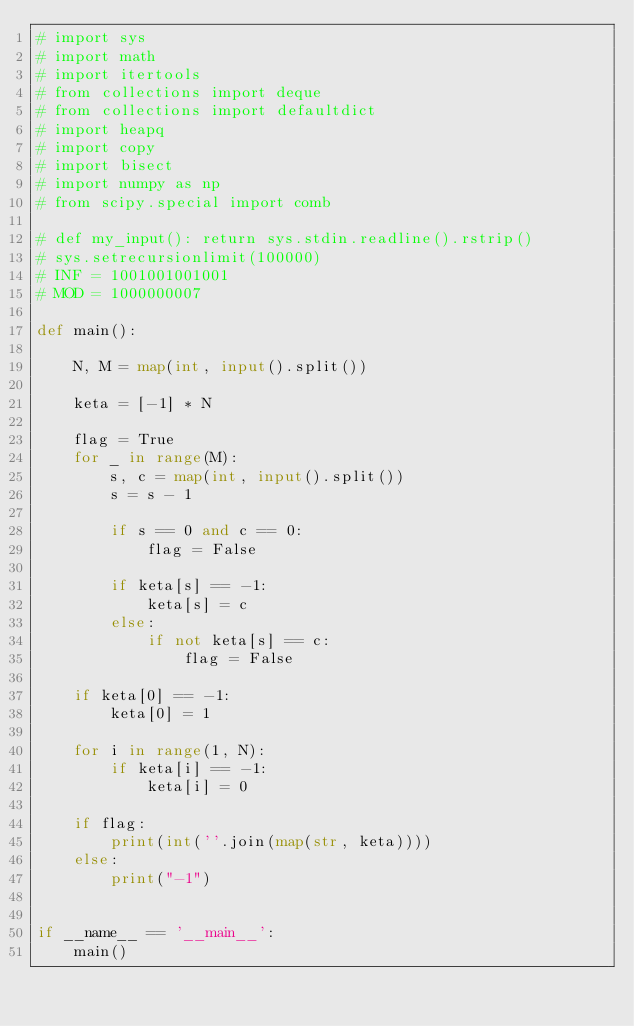Convert code to text. <code><loc_0><loc_0><loc_500><loc_500><_Python_># import sys
# import math
# import itertools
# from collections import deque
# from collections import defaultdict
# import heapq
# import copy
# import bisect
# import numpy as np
# from scipy.special import comb

# def my_input(): return sys.stdin.readline().rstrip()
# sys.setrecursionlimit(100000)
# INF = 1001001001001
# MOD = 1000000007

def main():

    N, M = map(int, input().split())

    keta = [-1] * N

    flag = True
    for _ in range(M):
        s, c = map(int, input().split())
        s = s - 1

        if s == 0 and c == 0:
            flag = False

        if keta[s] == -1:
            keta[s] = c
        else:
            if not keta[s] == c:
                flag = False

    if keta[0] == -1:
        keta[0] = 1

    for i in range(1, N):
        if keta[i] == -1:
            keta[i] = 0

    if flag:
        print(int(''.join(map(str, keta))))
    else:
        print("-1")


if __name__ == '__main__':
    main()
</code> 